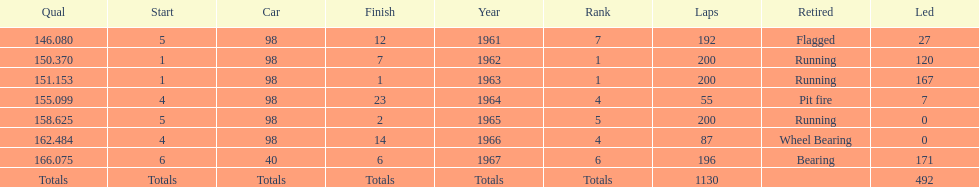How many total laps have been driven in the indy 500? 1130. 